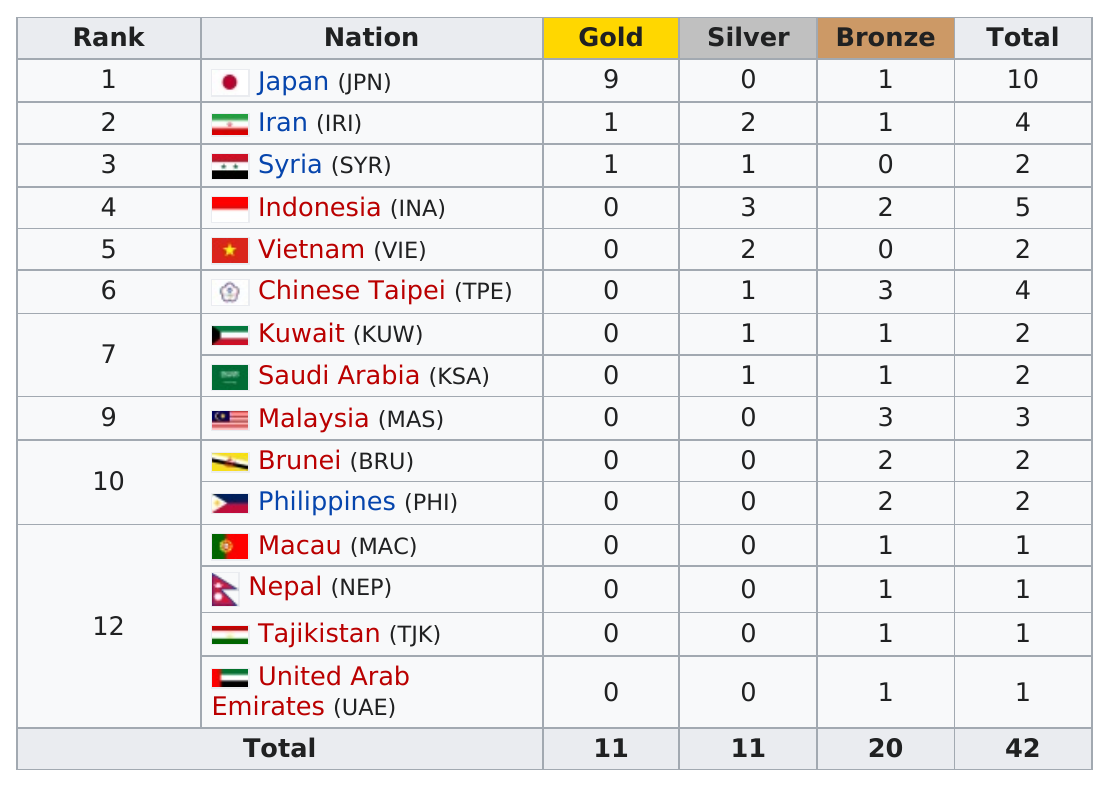Indicate a few pertinent items in this graphic. The total number of medals earned by all of the countries was 42. Indonesia is the country that has won the most silver medals. According to the information provided, Saudi Arabia has won one silver medal. The total number of medals received was 42. Two countries did not win any bronze medals. 